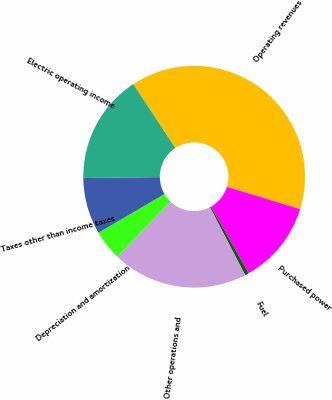Convert chart. <chart><loc_0><loc_0><loc_500><loc_500><pie_chart><fcel>Operating revenues<fcel>Purchased power<fcel>Fuel<fcel>Other operations and<fcel>Depreciation and amortization<fcel>Taxes other than income taxes<fcel>Electric operating income<nl><fcel>38.99%<fcel>12.09%<fcel>0.56%<fcel>19.77%<fcel>4.41%<fcel>8.25%<fcel>15.93%<nl></chart> 